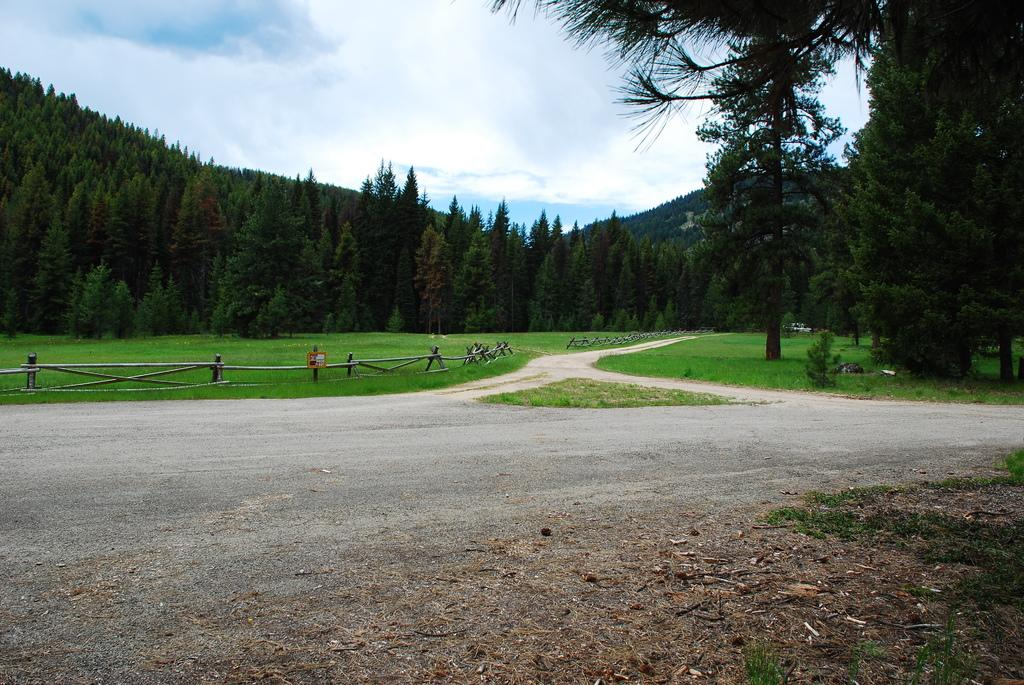What is the main feature of the image? There is a road in the image. What can be seen in the background of the image? There is a wooden railing, grassland, trees, a mountain, and the sky visible in the background of the image. What type of vegetation is present in the background? There are trees in the background of the image. What natural feature is visible in the distance? There is a mountain in the background of the image. What type of thunder can be heard in the image? There is no sound present in the image, so it is not possible to determine if any thunder can be heard. 